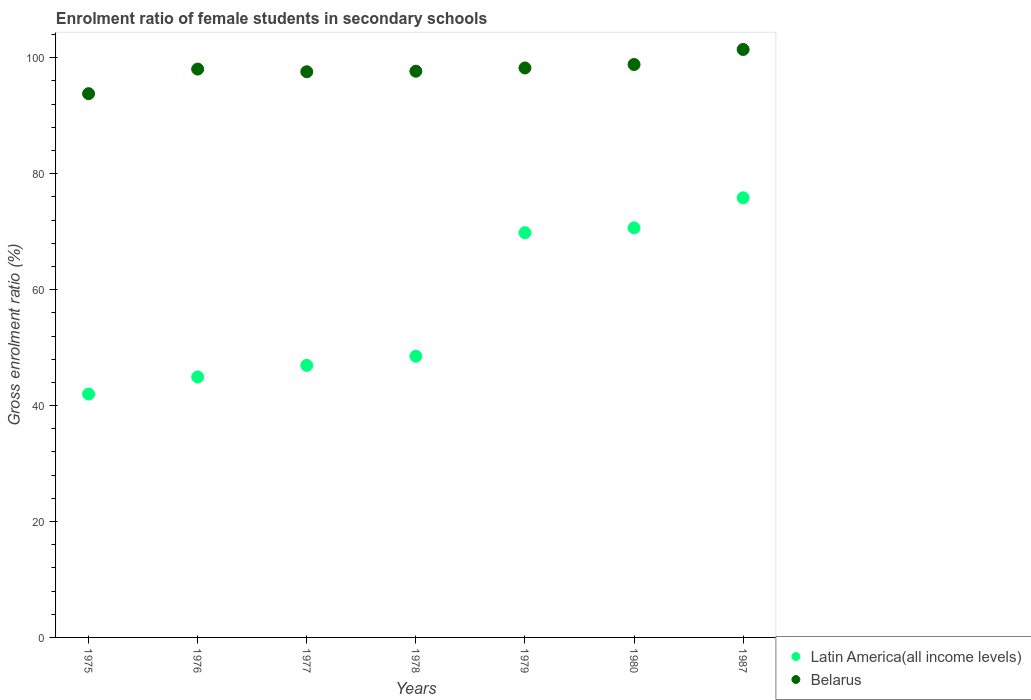Is the number of dotlines equal to the number of legend labels?
Provide a succinct answer. Yes. What is the enrolment ratio of female students in secondary schools in Latin America(all income levels) in 1979?
Your answer should be very brief. 69.82. Across all years, what is the maximum enrolment ratio of female students in secondary schools in Belarus?
Provide a succinct answer. 101.43. Across all years, what is the minimum enrolment ratio of female students in secondary schools in Belarus?
Your answer should be very brief. 93.81. In which year was the enrolment ratio of female students in secondary schools in Latin America(all income levels) minimum?
Your answer should be very brief. 1975. What is the total enrolment ratio of female students in secondary schools in Latin America(all income levels) in the graph?
Make the answer very short. 398.7. What is the difference between the enrolment ratio of female students in secondary schools in Belarus in 1975 and that in 1980?
Offer a very short reply. -5.04. What is the difference between the enrolment ratio of female students in secondary schools in Belarus in 1975 and the enrolment ratio of female students in secondary schools in Latin America(all income levels) in 1977?
Ensure brevity in your answer.  46.87. What is the average enrolment ratio of female students in secondary schools in Belarus per year?
Make the answer very short. 97.95. In the year 1978, what is the difference between the enrolment ratio of female students in secondary schools in Belarus and enrolment ratio of female students in secondary schools in Latin America(all income levels)?
Give a very brief answer. 49.17. What is the ratio of the enrolment ratio of female students in secondary schools in Belarus in 1975 to that in 1987?
Provide a succinct answer. 0.92. Is the difference between the enrolment ratio of female students in secondary schools in Belarus in 1976 and 1987 greater than the difference between the enrolment ratio of female students in secondary schools in Latin America(all income levels) in 1976 and 1987?
Offer a terse response. Yes. What is the difference between the highest and the second highest enrolment ratio of female students in secondary schools in Belarus?
Provide a succinct answer. 2.59. What is the difference between the highest and the lowest enrolment ratio of female students in secondary schools in Belarus?
Your answer should be compact. 7.63. In how many years, is the enrolment ratio of female students in secondary schools in Latin America(all income levels) greater than the average enrolment ratio of female students in secondary schools in Latin America(all income levels) taken over all years?
Your response must be concise. 3. Does the enrolment ratio of female students in secondary schools in Belarus monotonically increase over the years?
Give a very brief answer. No. Is the enrolment ratio of female students in secondary schools in Belarus strictly less than the enrolment ratio of female students in secondary schools in Latin America(all income levels) over the years?
Give a very brief answer. No. How many dotlines are there?
Your answer should be compact. 2. Does the graph contain grids?
Your answer should be compact. No. Where does the legend appear in the graph?
Provide a short and direct response. Bottom right. What is the title of the graph?
Make the answer very short. Enrolment ratio of female students in secondary schools. What is the label or title of the X-axis?
Keep it short and to the point. Years. What is the label or title of the Y-axis?
Provide a short and direct response. Gross enrolment ratio (%). What is the Gross enrolment ratio (%) of Latin America(all income levels) in 1975?
Give a very brief answer. 41.99. What is the Gross enrolment ratio (%) in Belarus in 1975?
Ensure brevity in your answer.  93.81. What is the Gross enrolment ratio (%) of Latin America(all income levels) in 1976?
Give a very brief answer. 44.93. What is the Gross enrolment ratio (%) of Belarus in 1976?
Provide a short and direct response. 98.05. What is the Gross enrolment ratio (%) of Latin America(all income levels) in 1977?
Provide a succinct answer. 46.93. What is the Gross enrolment ratio (%) of Belarus in 1977?
Your answer should be compact. 97.59. What is the Gross enrolment ratio (%) of Latin America(all income levels) in 1978?
Your answer should be compact. 48.51. What is the Gross enrolment ratio (%) in Belarus in 1978?
Provide a succinct answer. 97.68. What is the Gross enrolment ratio (%) in Latin America(all income levels) in 1979?
Make the answer very short. 69.82. What is the Gross enrolment ratio (%) in Belarus in 1979?
Make the answer very short. 98.24. What is the Gross enrolment ratio (%) in Latin America(all income levels) in 1980?
Keep it short and to the point. 70.66. What is the Gross enrolment ratio (%) in Belarus in 1980?
Make the answer very short. 98.84. What is the Gross enrolment ratio (%) of Latin America(all income levels) in 1987?
Your answer should be compact. 75.85. What is the Gross enrolment ratio (%) in Belarus in 1987?
Provide a short and direct response. 101.43. Across all years, what is the maximum Gross enrolment ratio (%) in Latin America(all income levels)?
Your answer should be compact. 75.85. Across all years, what is the maximum Gross enrolment ratio (%) in Belarus?
Keep it short and to the point. 101.43. Across all years, what is the minimum Gross enrolment ratio (%) of Latin America(all income levels)?
Make the answer very short. 41.99. Across all years, what is the minimum Gross enrolment ratio (%) in Belarus?
Provide a succinct answer. 93.81. What is the total Gross enrolment ratio (%) of Latin America(all income levels) in the graph?
Offer a very short reply. 398.7. What is the total Gross enrolment ratio (%) of Belarus in the graph?
Your answer should be very brief. 685.65. What is the difference between the Gross enrolment ratio (%) of Latin America(all income levels) in 1975 and that in 1976?
Your answer should be very brief. -2.94. What is the difference between the Gross enrolment ratio (%) in Belarus in 1975 and that in 1976?
Your answer should be compact. -4.24. What is the difference between the Gross enrolment ratio (%) of Latin America(all income levels) in 1975 and that in 1977?
Offer a very short reply. -4.94. What is the difference between the Gross enrolment ratio (%) in Belarus in 1975 and that in 1977?
Give a very brief answer. -3.79. What is the difference between the Gross enrolment ratio (%) in Latin America(all income levels) in 1975 and that in 1978?
Provide a short and direct response. -6.52. What is the difference between the Gross enrolment ratio (%) in Belarus in 1975 and that in 1978?
Provide a succinct answer. -3.88. What is the difference between the Gross enrolment ratio (%) of Latin America(all income levels) in 1975 and that in 1979?
Your answer should be very brief. -27.83. What is the difference between the Gross enrolment ratio (%) in Belarus in 1975 and that in 1979?
Your answer should be compact. -4.44. What is the difference between the Gross enrolment ratio (%) of Latin America(all income levels) in 1975 and that in 1980?
Provide a short and direct response. -28.67. What is the difference between the Gross enrolment ratio (%) of Belarus in 1975 and that in 1980?
Make the answer very short. -5.04. What is the difference between the Gross enrolment ratio (%) of Latin America(all income levels) in 1975 and that in 1987?
Provide a short and direct response. -33.86. What is the difference between the Gross enrolment ratio (%) in Belarus in 1975 and that in 1987?
Make the answer very short. -7.63. What is the difference between the Gross enrolment ratio (%) of Latin America(all income levels) in 1976 and that in 1977?
Offer a very short reply. -2. What is the difference between the Gross enrolment ratio (%) of Belarus in 1976 and that in 1977?
Make the answer very short. 0.46. What is the difference between the Gross enrolment ratio (%) in Latin America(all income levels) in 1976 and that in 1978?
Provide a succinct answer. -3.58. What is the difference between the Gross enrolment ratio (%) of Belarus in 1976 and that in 1978?
Offer a terse response. 0.37. What is the difference between the Gross enrolment ratio (%) in Latin America(all income levels) in 1976 and that in 1979?
Ensure brevity in your answer.  -24.89. What is the difference between the Gross enrolment ratio (%) in Belarus in 1976 and that in 1979?
Offer a terse response. -0.19. What is the difference between the Gross enrolment ratio (%) in Latin America(all income levels) in 1976 and that in 1980?
Your answer should be very brief. -25.73. What is the difference between the Gross enrolment ratio (%) of Belarus in 1976 and that in 1980?
Provide a short and direct response. -0.79. What is the difference between the Gross enrolment ratio (%) in Latin America(all income levels) in 1976 and that in 1987?
Your answer should be compact. -30.91. What is the difference between the Gross enrolment ratio (%) in Belarus in 1976 and that in 1987?
Provide a succinct answer. -3.38. What is the difference between the Gross enrolment ratio (%) in Latin America(all income levels) in 1977 and that in 1978?
Provide a succinct answer. -1.58. What is the difference between the Gross enrolment ratio (%) of Belarus in 1977 and that in 1978?
Provide a short and direct response. -0.09. What is the difference between the Gross enrolment ratio (%) in Latin America(all income levels) in 1977 and that in 1979?
Provide a short and direct response. -22.89. What is the difference between the Gross enrolment ratio (%) of Belarus in 1977 and that in 1979?
Provide a short and direct response. -0.65. What is the difference between the Gross enrolment ratio (%) of Latin America(all income levels) in 1977 and that in 1980?
Your answer should be very brief. -23.73. What is the difference between the Gross enrolment ratio (%) of Belarus in 1977 and that in 1980?
Make the answer very short. -1.25. What is the difference between the Gross enrolment ratio (%) of Latin America(all income levels) in 1977 and that in 1987?
Your answer should be very brief. -28.91. What is the difference between the Gross enrolment ratio (%) in Belarus in 1977 and that in 1987?
Your answer should be very brief. -3.84. What is the difference between the Gross enrolment ratio (%) in Latin America(all income levels) in 1978 and that in 1979?
Make the answer very short. -21.31. What is the difference between the Gross enrolment ratio (%) of Belarus in 1978 and that in 1979?
Your answer should be compact. -0.56. What is the difference between the Gross enrolment ratio (%) in Latin America(all income levels) in 1978 and that in 1980?
Keep it short and to the point. -22.15. What is the difference between the Gross enrolment ratio (%) of Belarus in 1978 and that in 1980?
Provide a short and direct response. -1.16. What is the difference between the Gross enrolment ratio (%) of Latin America(all income levels) in 1978 and that in 1987?
Your answer should be compact. -27.34. What is the difference between the Gross enrolment ratio (%) in Belarus in 1978 and that in 1987?
Make the answer very short. -3.75. What is the difference between the Gross enrolment ratio (%) of Latin America(all income levels) in 1979 and that in 1980?
Your answer should be compact. -0.84. What is the difference between the Gross enrolment ratio (%) in Belarus in 1979 and that in 1980?
Offer a very short reply. -0.6. What is the difference between the Gross enrolment ratio (%) of Latin America(all income levels) in 1979 and that in 1987?
Give a very brief answer. -6.02. What is the difference between the Gross enrolment ratio (%) in Belarus in 1979 and that in 1987?
Offer a very short reply. -3.19. What is the difference between the Gross enrolment ratio (%) of Latin America(all income levels) in 1980 and that in 1987?
Your answer should be compact. -5.18. What is the difference between the Gross enrolment ratio (%) in Belarus in 1980 and that in 1987?
Your answer should be very brief. -2.59. What is the difference between the Gross enrolment ratio (%) of Latin America(all income levels) in 1975 and the Gross enrolment ratio (%) of Belarus in 1976?
Ensure brevity in your answer.  -56.06. What is the difference between the Gross enrolment ratio (%) in Latin America(all income levels) in 1975 and the Gross enrolment ratio (%) in Belarus in 1977?
Keep it short and to the point. -55.6. What is the difference between the Gross enrolment ratio (%) in Latin America(all income levels) in 1975 and the Gross enrolment ratio (%) in Belarus in 1978?
Provide a short and direct response. -55.69. What is the difference between the Gross enrolment ratio (%) in Latin America(all income levels) in 1975 and the Gross enrolment ratio (%) in Belarus in 1979?
Your answer should be compact. -56.25. What is the difference between the Gross enrolment ratio (%) in Latin America(all income levels) in 1975 and the Gross enrolment ratio (%) in Belarus in 1980?
Give a very brief answer. -56.85. What is the difference between the Gross enrolment ratio (%) of Latin America(all income levels) in 1975 and the Gross enrolment ratio (%) of Belarus in 1987?
Provide a short and direct response. -59.44. What is the difference between the Gross enrolment ratio (%) of Latin America(all income levels) in 1976 and the Gross enrolment ratio (%) of Belarus in 1977?
Give a very brief answer. -52.66. What is the difference between the Gross enrolment ratio (%) in Latin America(all income levels) in 1976 and the Gross enrolment ratio (%) in Belarus in 1978?
Provide a succinct answer. -52.75. What is the difference between the Gross enrolment ratio (%) of Latin America(all income levels) in 1976 and the Gross enrolment ratio (%) of Belarus in 1979?
Provide a short and direct response. -53.31. What is the difference between the Gross enrolment ratio (%) in Latin America(all income levels) in 1976 and the Gross enrolment ratio (%) in Belarus in 1980?
Offer a very short reply. -53.91. What is the difference between the Gross enrolment ratio (%) of Latin America(all income levels) in 1976 and the Gross enrolment ratio (%) of Belarus in 1987?
Offer a terse response. -56.5. What is the difference between the Gross enrolment ratio (%) of Latin America(all income levels) in 1977 and the Gross enrolment ratio (%) of Belarus in 1978?
Make the answer very short. -50.75. What is the difference between the Gross enrolment ratio (%) of Latin America(all income levels) in 1977 and the Gross enrolment ratio (%) of Belarus in 1979?
Your answer should be compact. -51.31. What is the difference between the Gross enrolment ratio (%) in Latin America(all income levels) in 1977 and the Gross enrolment ratio (%) in Belarus in 1980?
Provide a succinct answer. -51.91. What is the difference between the Gross enrolment ratio (%) of Latin America(all income levels) in 1977 and the Gross enrolment ratio (%) of Belarus in 1987?
Give a very brief answer. -54.5. What is the difference between the Gross enrolment ratio (%) in Latin America(all income levels) in 1978 and the Gross enrolment ratio (%) in Belarus in 1979?
Offer a terse response. -49.73. What is the difference between the Gross enrolment ratio (%) of Latin America(all income levels) in 1978 and the Gross enrolment ratio (%) of Belarus in 1980?
Your response must be concise. -50.33. What is the difference between the Gross enrolment ratio (%) of Latin America(all income levels) in 1978 and the Gross enrolment ratio (%) of Belarus in 1987?
Your response must be concise. -52.92. What is the difference between the Gross enrolment ratio (%) in Latin America(all income levels) in 1979 and the Gross enrolment ratio (%) in Belarus in 1980?
Make the answer very short. -29.02. What is the difference between the Gross enrolment ratio (%) in Latin America(all income levels) in 1979 and the Gross enrolment ratio (%) in Belarus in 1987?
Ensure brevity in your answer.  -31.61. What is the difference between the Gross enrolment ratio (%) of Latin America(all income levels) in 1980 and the Gross enrolment ratio (%) of Belarus in 1987?
Ensure brevity in your answer.  -30.77. What is the average Gross enrolment ratio (%) in Latin America(all income levels) per year?
Offer a very short reply. 56.96. What is the average Gross enrolment ratio (%) in Belarus per year?
Keep it short and to the point. 97.95. In the year 1975, what is the difference between the Gross enrolment ratio (%) in Latin America(all income levels) and Gross enrolment ratio (%) in Belarus?
Your answer should be very brief. -51.82. In the year 1976, what is the difference between the Gross enrolment ratio (%) in Latin America(all income levels) and Gross enrolment ratio (%) in Belarus?
Keep it short and to the point. -53.12. In the year 1977, what is the difference between the Gross enrolment ratio (%) of Latin America(all income levels) and Gross enrolment ratio (%) of Belarus?
Ensure brevity in your answer.  -50.66. In the year 1978, what is the difference between the Gross enrolment ratio (%) of Latin America(all income levels) and Gross enrolment ratio (%) of Belarus?
Your answer should be very brief. -49.17. In the year 1979, what is the difference between the Gross enrolment ratio (%) of Latin America(all income levels) and Gross enrolment ratio (%) of Belarus?
Make the answer very short. -28.42. In the year 1980, what is the difference between the Gross enrolment ratio (%) of Latin America(all income levels) and Gross enrolment ratio (%) of Belarus?
Offer a terse response. -28.18. In the year 1987, what is the difference between the Gross enrolment ratio (%) in Latin America(all income levels) and Gross enrolment ratio (%) in Belarus?
Provide a succinct answer. -25.59. What is the ratio of the Gross enrolment ratio (%) of Latin America(all income levels) in 1975 to that in 1976?
Provide a short and direct response. 0.93. What is the ratio of the Gross enrolment ratio (%) of Belarus in 1975 to that in 1976?
Offer a very short reply. 0.96. What is the ratio of the Gross enrolment ratio (%) of Latin America(all income levels) in 1975 to that in 1977?
Your answer should be compact. 0.89. What is the ratio of the Gross enrolment ratio (%) in Belarus in 1975 to that in 1977?
Your response must be concise. 0.96. What is the ratio of the Gross enrolment ratio (%) in Latin America(all income levels) in 1975 to that in 1978?
Keep it short and to the point. 0.87. What is the ratio of the Gross enrolment ratio (%) in Belarus in 1975 to that in 1978?
Your answer should be very brief. 0.96. What is the ratio of the Gross enrolment ratio (%) of Latin America(all income levels) in 1975 to that in 1979?
Your answer should be very brief. 0.6. What is the ratio of the Gross enrolment ratio (%) of Belarus in 1975 to that in 1979?
Make the answer very short. 0.95. What is the ratio of the Gross enrolment ratio (%) in Latin America(all income levels) in 1975 to that in 1980?
Your response must be concise. 0.59. What is the ratio of the Gross enrolment ratio (%) in Belarus in 1975 to that in 1980?
Your answer should be compact. 0.95. What is the ratio of the Gross enrolment ratio (%) in Latin America(all income levels) in 1975 to that in 1987?
Ensure brevity in your answer.  0.55. What is the ratio of the Gross enrolment ratio (%) of Belarus in 1975 to that in 1987?
Keep it short and to the point. 0.92. What is the ratio of the Gross enrolment ratio (%) of Latin America(all income levels) in 1976 to that in 1977?
Provide a short and direct response. 0.96. What is the ratio of the Gross enrolment ratio (%) in Latin America(all income levels) in 1976 to that in 1978?
Give a very brief answer. 0.93. What is the ratio of the Gross enrolment ratio (%) in Belarus in 1976 to that in 1978?
Provide a short and direct response. 1. What is the ratio of the Gross enrolment ratio (%) in Latin America(all income levels) in 1976 to that in 1979?
Make the answer very short. 0.64. What is the ratio of the Gross enrolment ratio (%) of Belarus in 1976 to that in 1979?
Keep it short and to the point. 1. What is the ratio of the Gross enrolment ratio (%) in Latin America(all income levels) in 1976 to that in 1980?
Offer a very short reply. 0.64. What is the ratio of the Gross enrolment ratio (%) of Belarus in 1976 to that in 1980?
Your response must be concise. 0.99. What is the ratio of the Gross enrolment ratio (%) of Latin America(all income levels) in 1976 to that in 1987?
Keep it short and to the point. 0.59. What is the ratio of the Gross enrolment ratio (%) in Belarus in 1976 to that in 1987?
Your answer should be compact. 0.97. What is the ratio of the Gross enrolment ratio (%) of Latin America(all income levels) in 1977 to that in 1978?
Offer a terse response. 0.97. What is the ratio of the Gross enrolment ratio (%) in Latin America(all income levels) in 1977 to that in 1979?
Your response must be concise. 0.67. What is the ratio of the Gross enrolment ratio (%) in Belarus in 1977 to that in 1979?
Your answer should be very brief. 0.99. What is the ratio of the Gross enrolment ratio (%) of Latin America(all income levels) in 1977 to that in 1980?
Give a very brief answer. 0.66. What is the ratio of the Gross enrolment ratio (%) in Belarus in 1977 to that in 1980?
Your response must be concise. 0.99. What is the ratio of the Gross enrolment ratio (%) of Latin America(all income levels) in 1977 to that in 1987?
Your answer should be compact. 0.62. What is the ratio of the Gross enrolment ratio (%) in Belarus in 1977 to that in 1987?
Give a very brief answer. 0.96. What is the ratio of the Gross enrolment ratio (%) of Latin America(all income levels) in 1978 to that in 1979?
Make the answer very short. 0.69. What is the ratio of the Gross enrolment ratio (%) in Latin America(all income levels) in 1978 to that in 1980?
Offer a terse response. 0.69. What is the ratio of the Gross enrolment ratio (%) in Belarus in 1978 to that in 1980?
Provide a succinct answer. 0.99. What is the ratio of the Gross enrolment ratio (%) of Latin America(all income levels) in 1978 to that in 1987?
Your response must be concise. 0.64. What is the ratio of the Gross enrolment ratio (%) of Belarus in 1978 to that in 1987?
Offer a terse response. 0.96. What is the ratio of the Gross enrolment ratio (%) of Latin America(all income levels) in 1979 to that in 1987?
Ensure brevity in your answer.  0.92. What is the ratio of the Gross enrolment ratio (%) in Belarus in 1979 to that in 1987?
Your answer should be compact. 0.97. What is the ratio of the Gross enrolment ratio (%) of Latin America(all income levels) in 1980 to that in 1987?
Your answer should be very brief. 0.93. What is the ratio of the Gross enrolment ratio (%) of Belarus in 1980 to that in 1987?
Offer a terse response. 0.97. What is the difference between the highest and the second highest Gross enrolment ratio (%) of Latin America(all income levels)?
Offer a very short reply. 5.18. What is the difference between the highest and the second highest Gross enrolment ratio (%) of Belarus?
Provide a short and direct response. 2.59. What is the difference between the highest and the lowest Gross enrolment ratio (%) of Latin America(all income levels)?
Give a very brief answer. 33.86. What is the difference between the highest and the lowest Gross enrolment ratio (%) in Belarus?
Your answer should be compact. 7.63. 